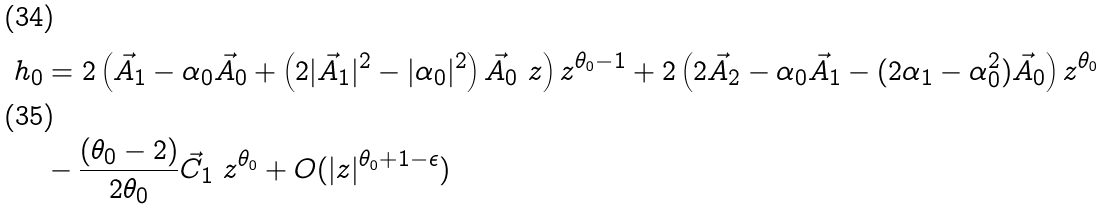Convert formula to latex. <formula><loc_0><loc_0><loc_500><loc_500>\ h _ { 0 } & = 2 \left ( \vec { A } _ { 1 } - \alpha _ { 0 } \vec { A } _ { 0 } + \left ( 2 | \vec { A } _ { 1 } | ^ { 2 } - | \alpha _ { 0 } | ^ { 2 } \right ) \vec { A } _ { 0 } \ z \right ) z ^ { \theta _ { 0 } - 1 } + 2 \left ( 2 \vec { A } _ { 2 } - \alpha _ { 0 } \vec { A } _ { 1 } - ( 2 \alpha _ { 1 } - \alpha _ { 0 } ^ { 2 } ) \vec { A } _ { 0 } \right ) z ^ { \theta _ { 0 } } \\ & - \frac { ( \theta _ { 0 } - 2 ) } { 2 \theta _ { 0 } } \vec { C } _ { 1 } \ z ^ { \theta _ { 0 } } + O ( | z | ^ { \theta _ { 0 } + 1 - \epsilon } )</formula> 